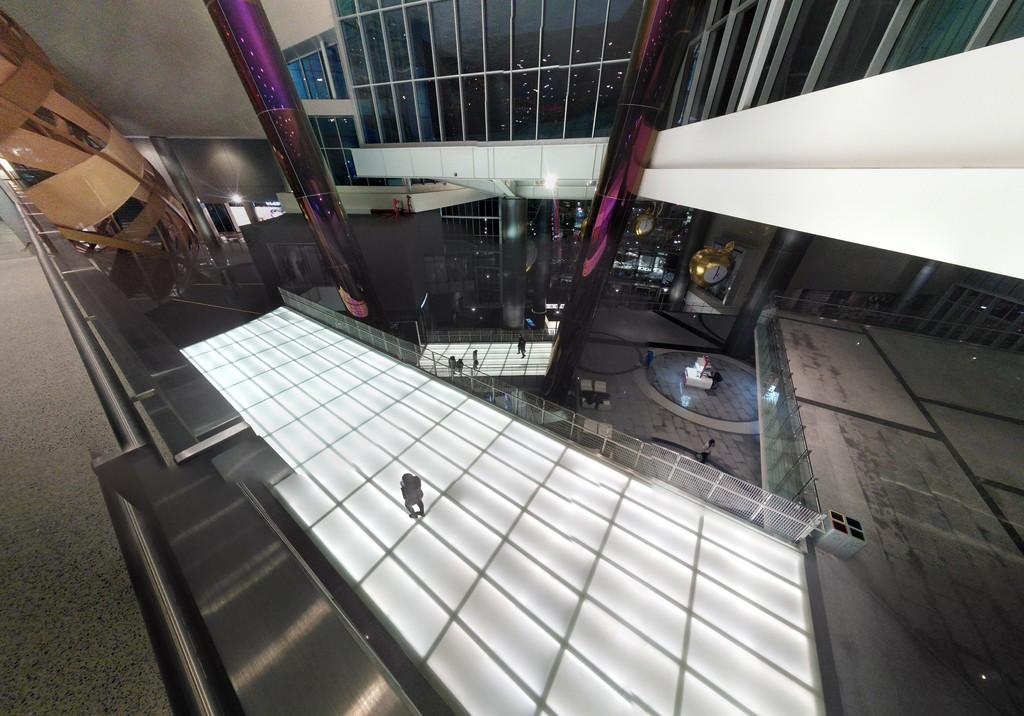What type of location is depicted in the image? The image shows the inside of a building. Can you describe the people present in the image? There are people standing in the image. What are some of the actions being performed by the people in the image? There are people walking in the image. What type of waves can be seen crashing against the mouth in the image? There are no waves or mouth present in the image; it depicts the inside of a building with people standing and walking. 